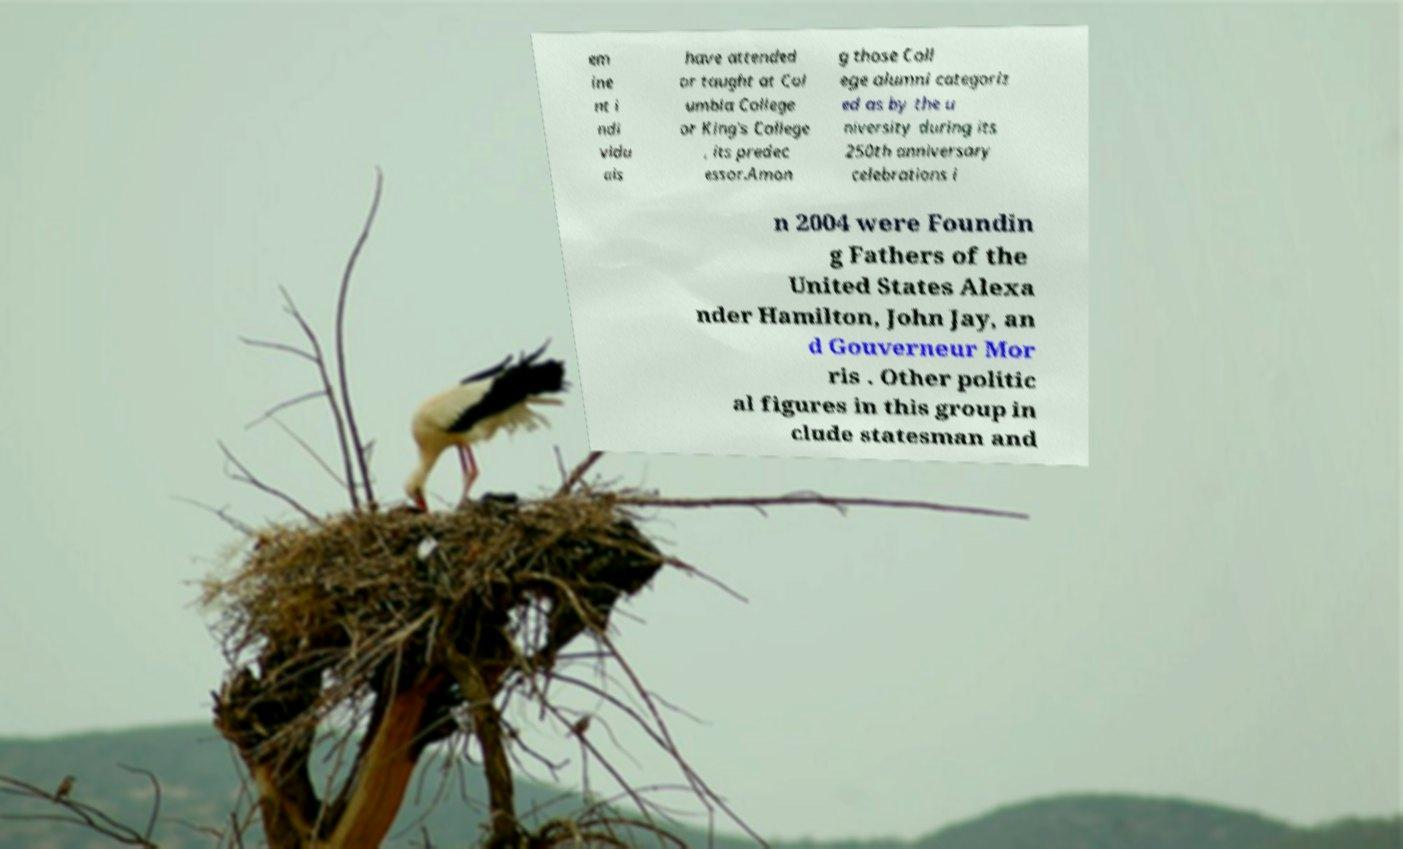Can you read and provide the text displayed in the image?This photo seems to have some interesting text. Can you extract and type it out for me? em ine nt i ndi vidu als have attended or taught at Col umbia College or King's College , its predec essor.Amon g those Coll ege alumni categoriz ed as by the u niversity during its 250th anniversary celebrations i n 2004 were Foundin g Fathers of the United States Alexa nder Hamilton, John Jay, an d Gouverneur Mor ris . Other politic al figures in this group in clude statesman and 